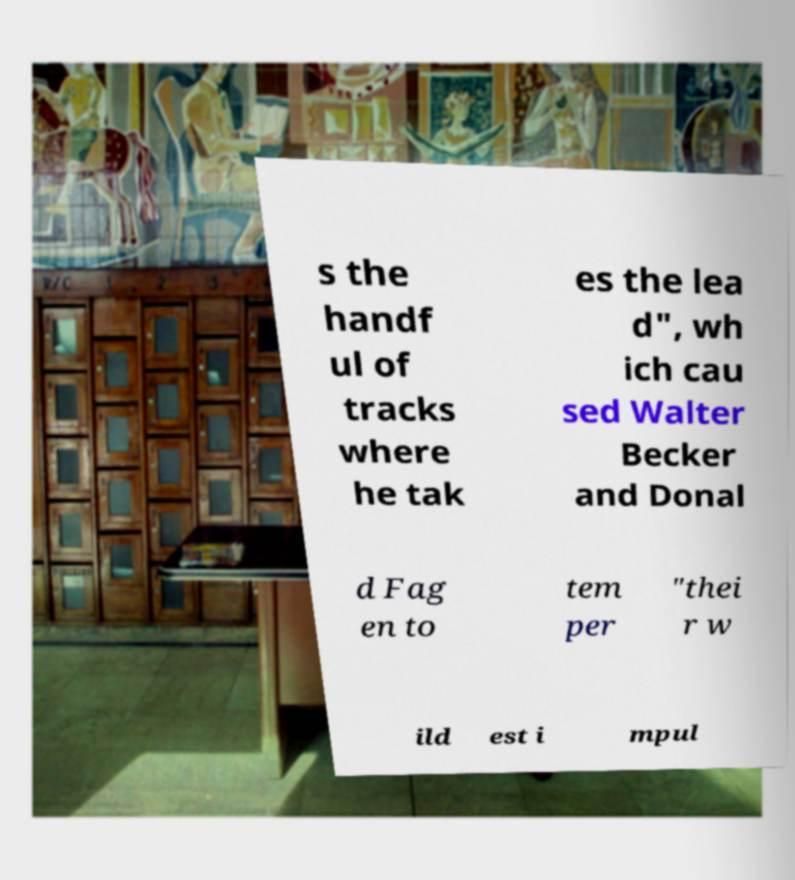Could you extract and type out the text from this image? s the handf ul of tracks where he tak es the lea d", wh ich cau sed Walter Becker and Donal d Fag en to tem per "thei r w ild est i mpul 